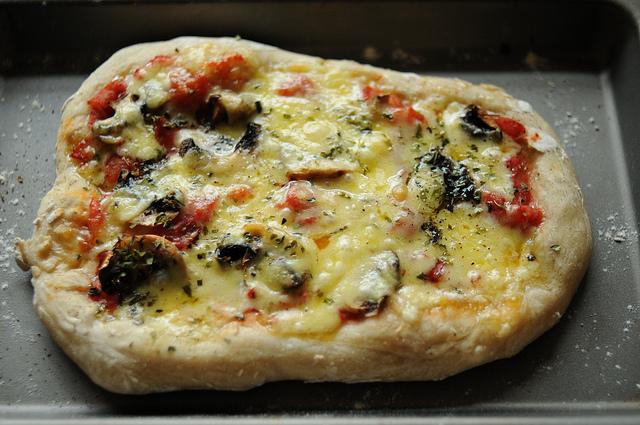What is on top of the pizza?
Concise answer only. Cheese. What kind of food is this?
Keep it brief. Pizza. Is the pizza baked?
Give a very brief answer. Yes. What is sprinkled on the pizza?
Keep it brief. Oregano. Does this look like a scene from a kitchen, or from a restaurant?
Quick response, please. Kitchen. 